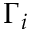Convert formula to latex. <formula><loc_0><loc_0><loc_500><loc_500>\Gamma _ { i }</formula> 